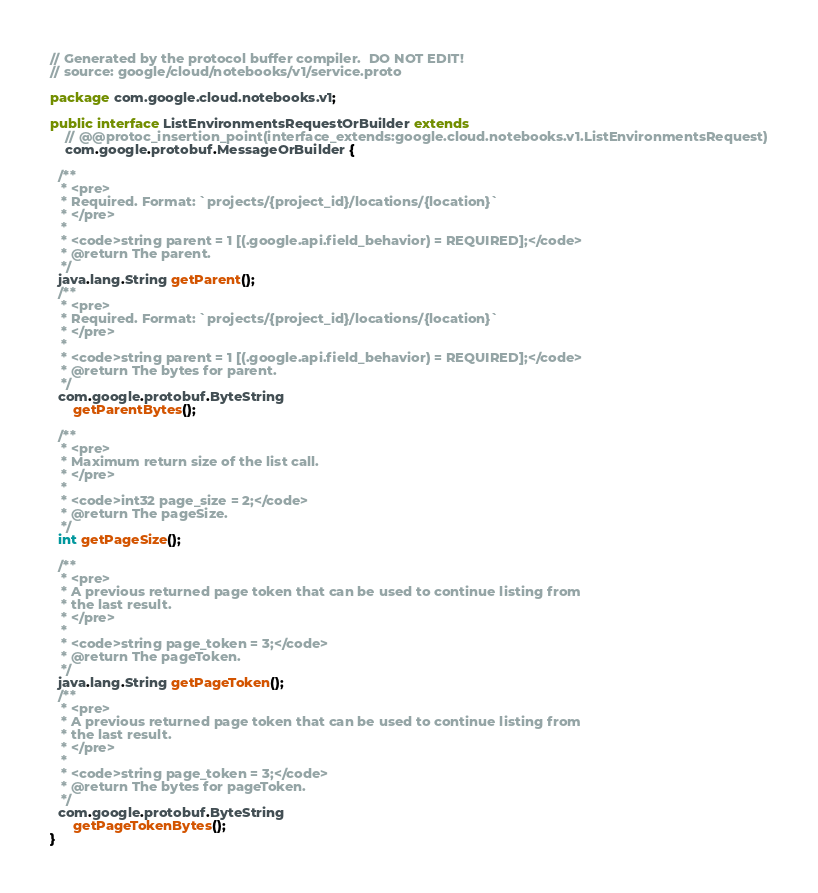<code> <loc_0><loc_0><loc_500><loc_500><_Java_>// Generated by the protocol buffer compiler.  DO NOT EDIT!
// source: google/cloud/notebooks/v1/service.proto

package com.google.cloud.notebooks.v1;

public interface ListEnvironmentsRequestOrBuilder extends
    // @@protoc_insertion_point(interface_extends:google.cloud.notebooks.v1.ListEnvironmentsRequest)
    com.google.protobuf.MessageOrBuilder {

  /**
   * <pre>
   * Required. Format: `projects/{project_id}/locations/{location}`
   * </pre>
   *
   * <code>string parent = 1 [(.google.api.field_behavior) = REQUIRED];</code>
   * @return The parent.
   */
  java.lang.String getParent();
  /**
   * <pre>
   * Required. Format: `projects/{project_id}/locations/{location}`
   * </pre>
   *
   * <code>string parent = 1 [(.google.api.field_behavior) = REQUIRED];</code>
   * @return The bytes for parent.
   */
  com.google.protobuf.ByteString
      getParentBytes();

  /**
   * <pre>
   * Maximum return size of the list call.
   * </pre>
   *
   * <code>int32 page_size = 2;</code>
   * @return The pageSize.
   */
  int getPageSize();

  /**
   * <pre>
   * A previous returned page token that can be used to continue listing from
   * the last result.
   * </pre>
   *
   * <code>string page_token = 3;</code>
   * @return The pageToken.
   */
  java.lang.String getPageToken();
  /**
   * <pre>
   * A previous returned page token that can be used to continue listing from
   * the last result.
   * </pre>
   *
   * <code>string page_token = 3;</code>
   * @return The bytes for pageToken.
   */
  com.google.protobuf.ByteString
      getPageTokenBytes();
}
</code> 